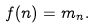Convert formula to latex. <formula><loc_0><loc_0><loc_500><loc_500>f ( n ) = m _ { n } .</formula> 